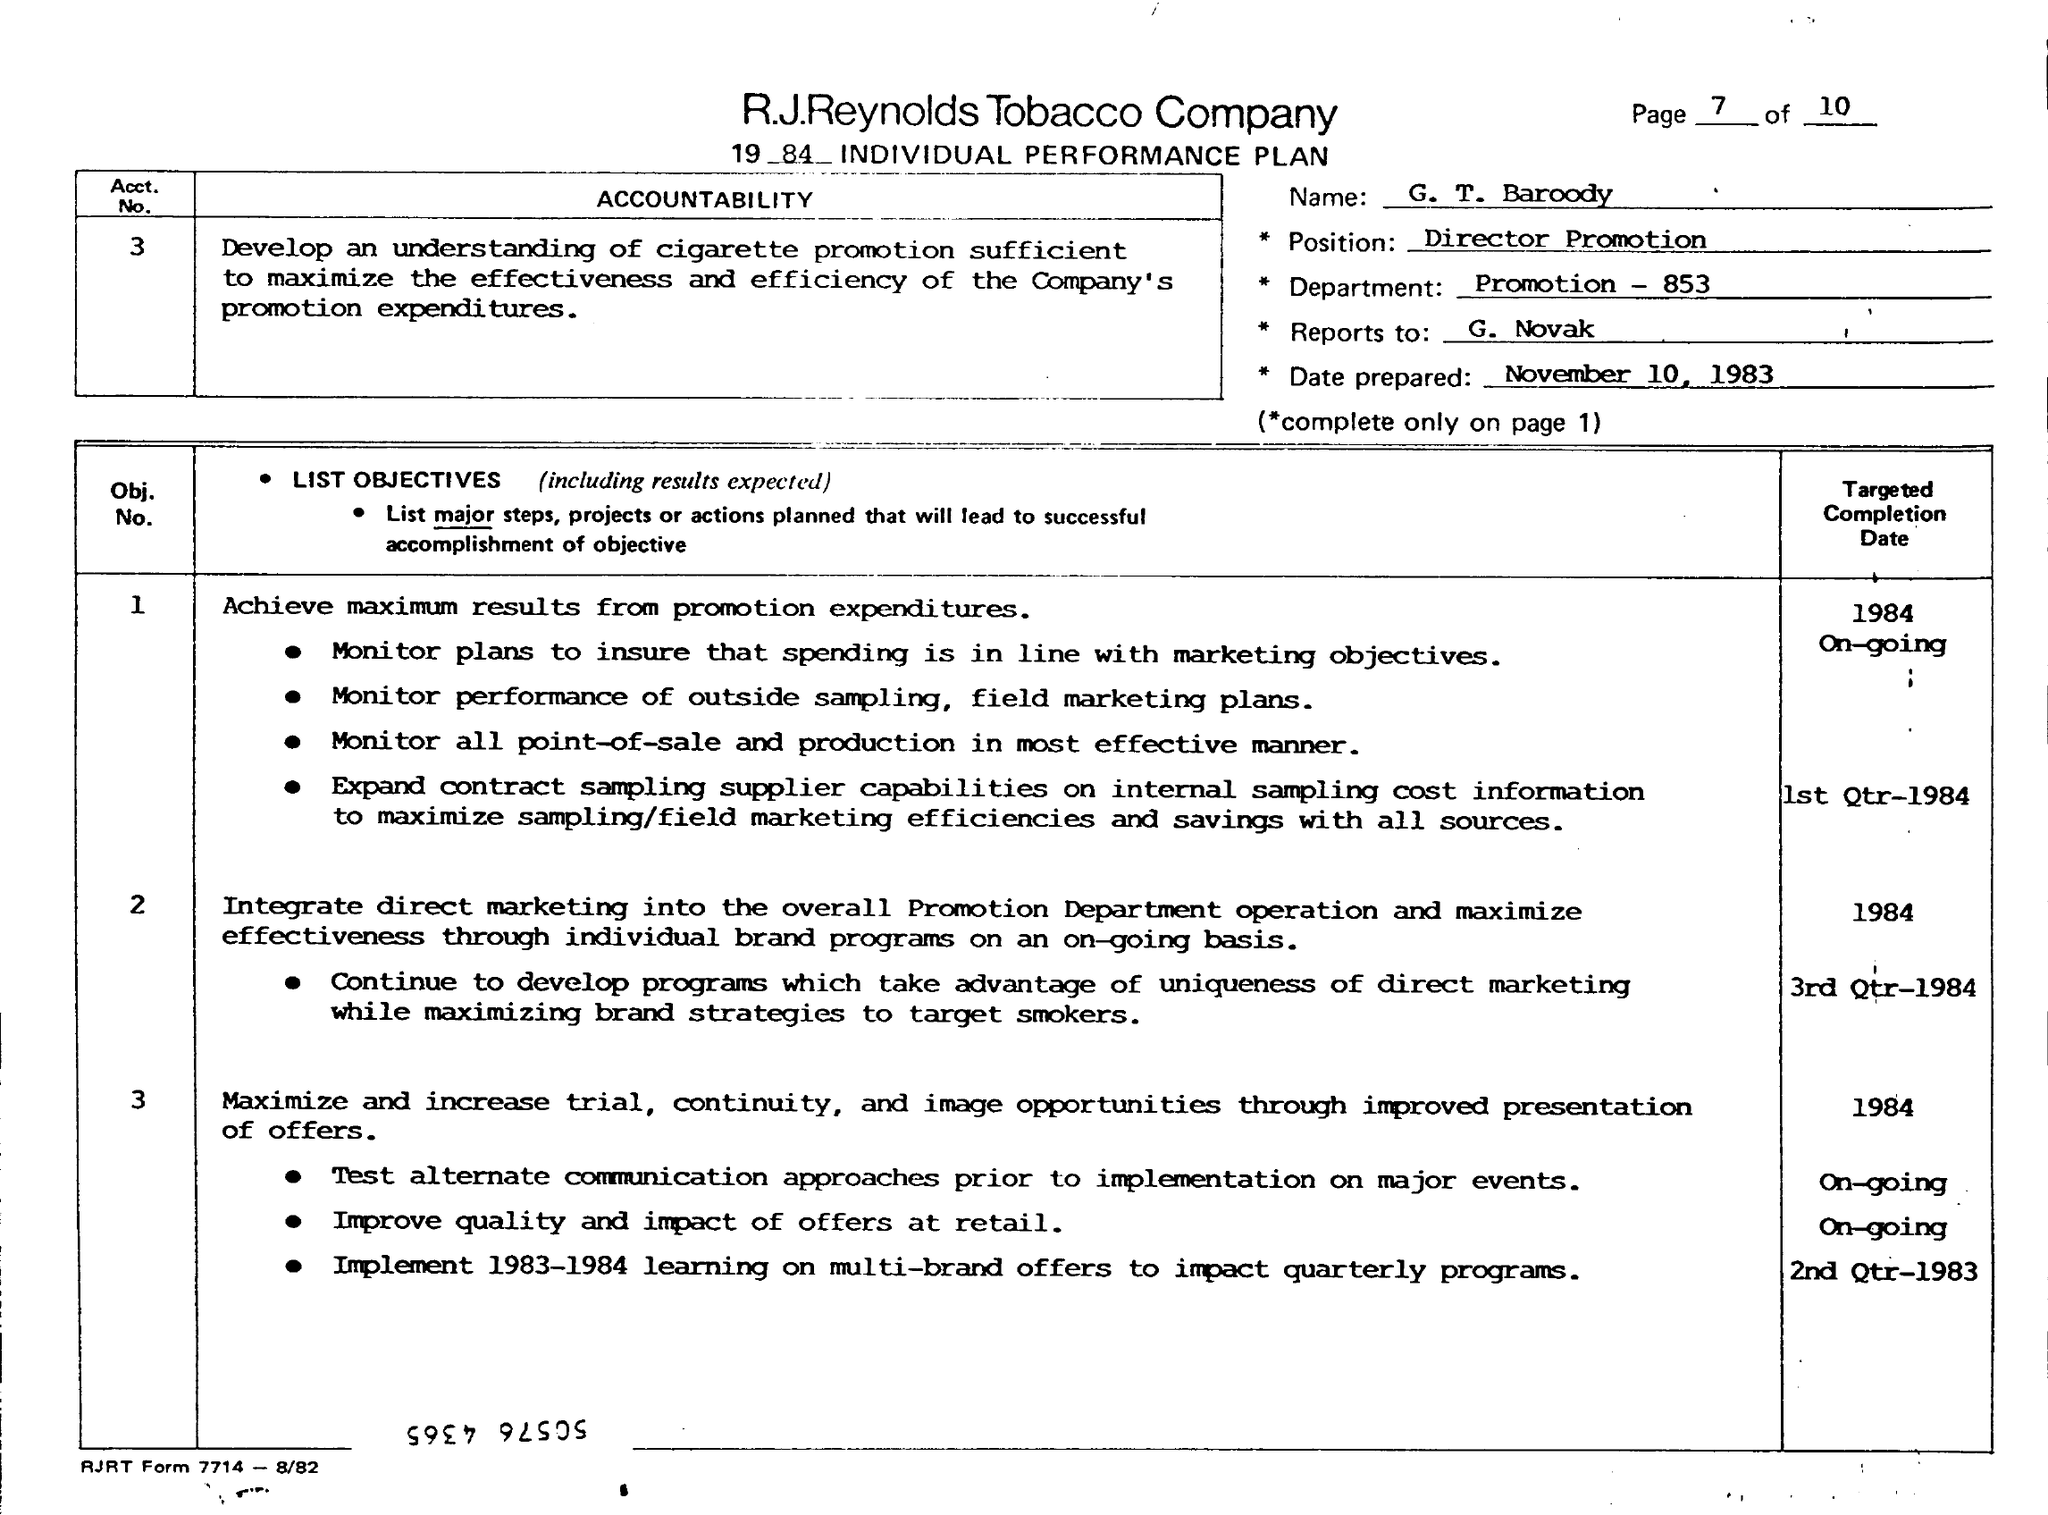Point out several critical features in this image. What is the name? The individual in question is G.T. Baroody. This date was prepared on November 10, 1983. The department is a promotion, with a number 853. The individual reported to G. Novak. 